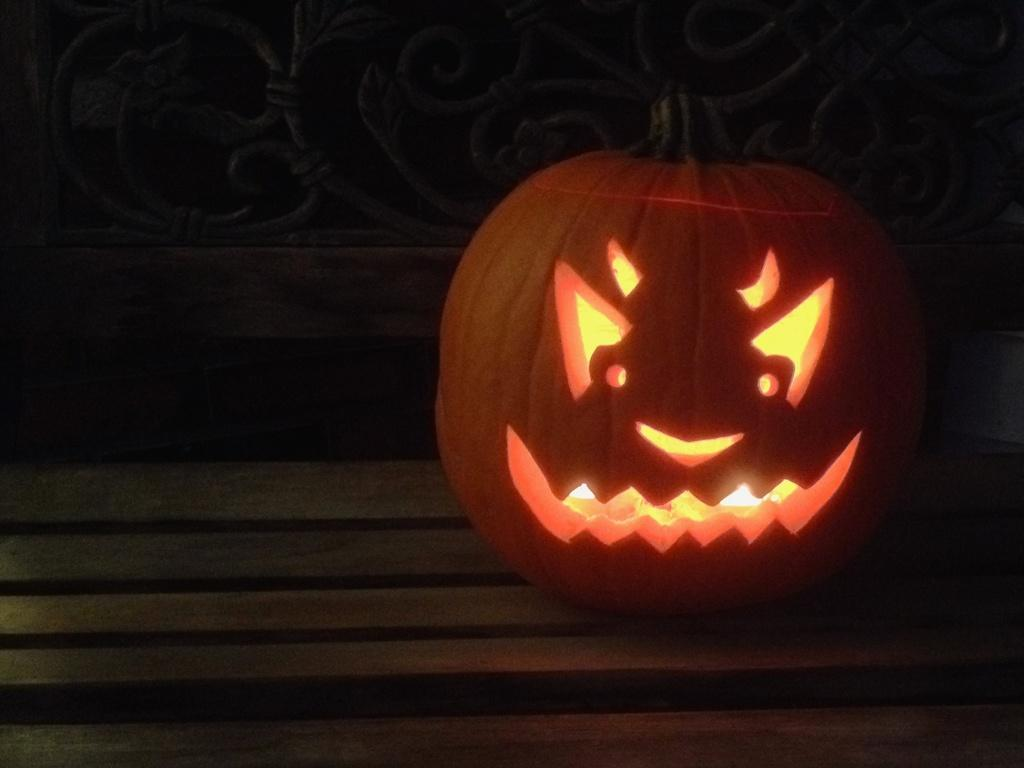What is the main object in the image? There is a pumpkin in the image. What is unique about the pumpkin? The pumpkin has lights and is carved. What is the pumpkin placed on? The pumpkin is on a wooden surface. What architectural feature can be seen in the image? There is a railing visible in the image. What is the color of the background in the image? The background of the image is black. What channel is the pumpkin watching in the image? There is no indication that the pumpkin is watching a channel or any form of media in the image. 